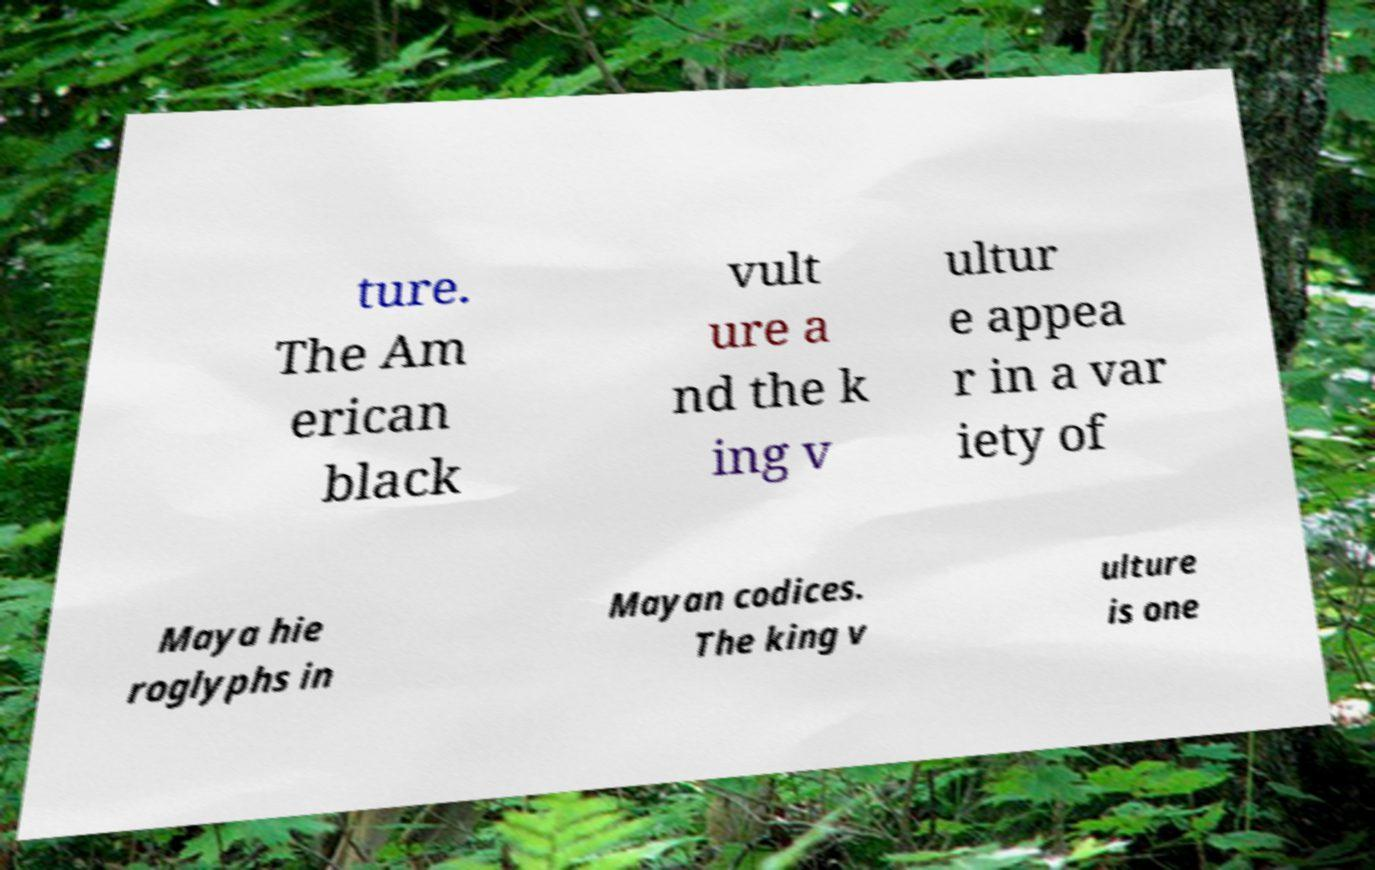Can you read and provide the text displayed in the image?This photo seems to have some interesting text. Can you extract and type it out for me? ture. The Am erican black vult ure a nd the k ing v ultur e appea r in a var iety of Maya hie roglyphs in Mayan codices. The king v ulture is one 